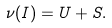<formula> <loc_0><loc_0><loc_500><loc_500>\nu ( I ) = U + S .</formula> 